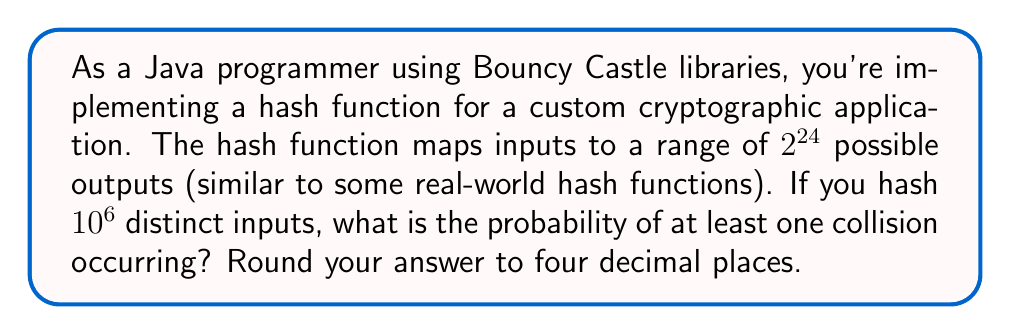Could you help me with this problem? To solve this problem, we'll use the birthday paradox principle and modular arithmetic concepts:

1) First, let's define our variables:
   $n = 2^{24}$ (number of possible hash outputs)
   $k = 10^6$ (number of inputs we're hashing)

2) The probability of at least one collision is easier to calculate by first finding the probability of no collisions and then subtracting from 1.

3) The probability of no collisions can be calculated as:

   $$P(\text{no collision}) = \frac{n!}{n^k(n-k)!}$$

4) However, this formula is impractical for large numbers. We can approximate it using the exponential function:

   $$P(\text{no collision}) \approx e^{-k(k-1)/(2n)}$$

5) Substituting our values:

   $$P(\text{no collision}) \approx e^{-10^6(10^6-1)/(2 \cdot 2^{24})}$$

6) Simplify:
   $$\approx e^{-(10^{12}-10^6)/(2^{25})}$$
   $$\approx e^{-5.96046448 \cdot 10^{-6}}$$

7) Calculate:
   $$\approx 0.9999940395$$

8) The probability of at least one collision is:

   $$P(\text{at least one collision}) = 1 - P(\text{no collision})$$
   $$= 1 - 0.9999940395$$
   $$= 0.0000059605$$

9) Rounding to four decimal places:
   $$\approx 0.0000$$
Answer: $0.0000$ 